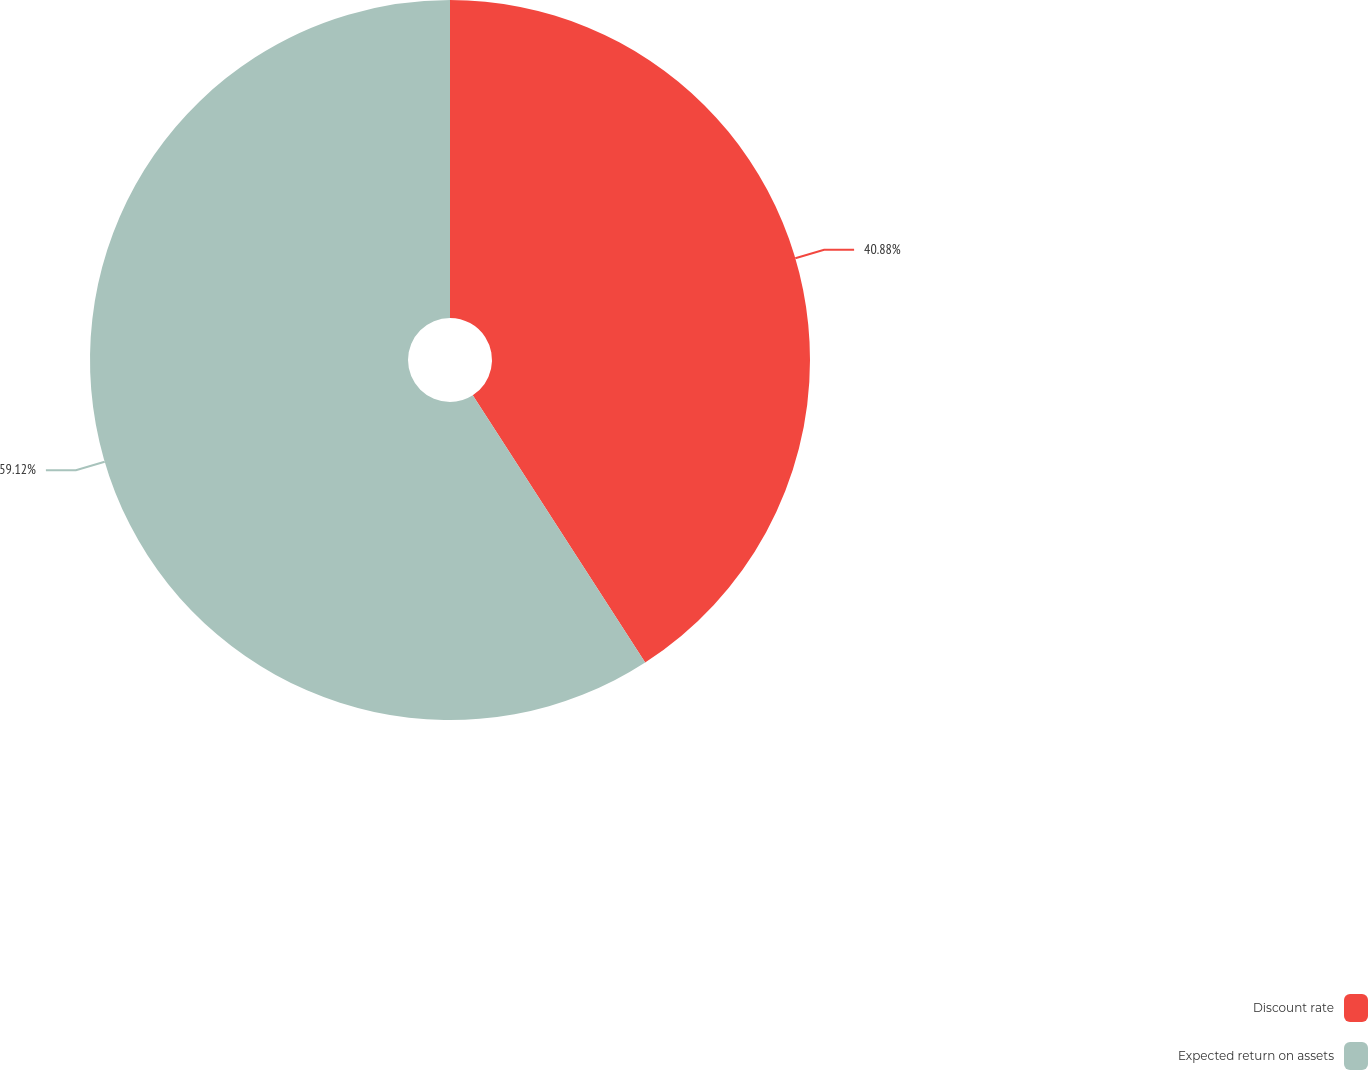Convert chart to OTSL. <chart><loc_0><loc_0><loc_500><loc_500><pie_chart><fcel>Discount rate<fcel>Expected return on assets<nl><fcel>40.88%<fcel>59.12%<nl></chart> 